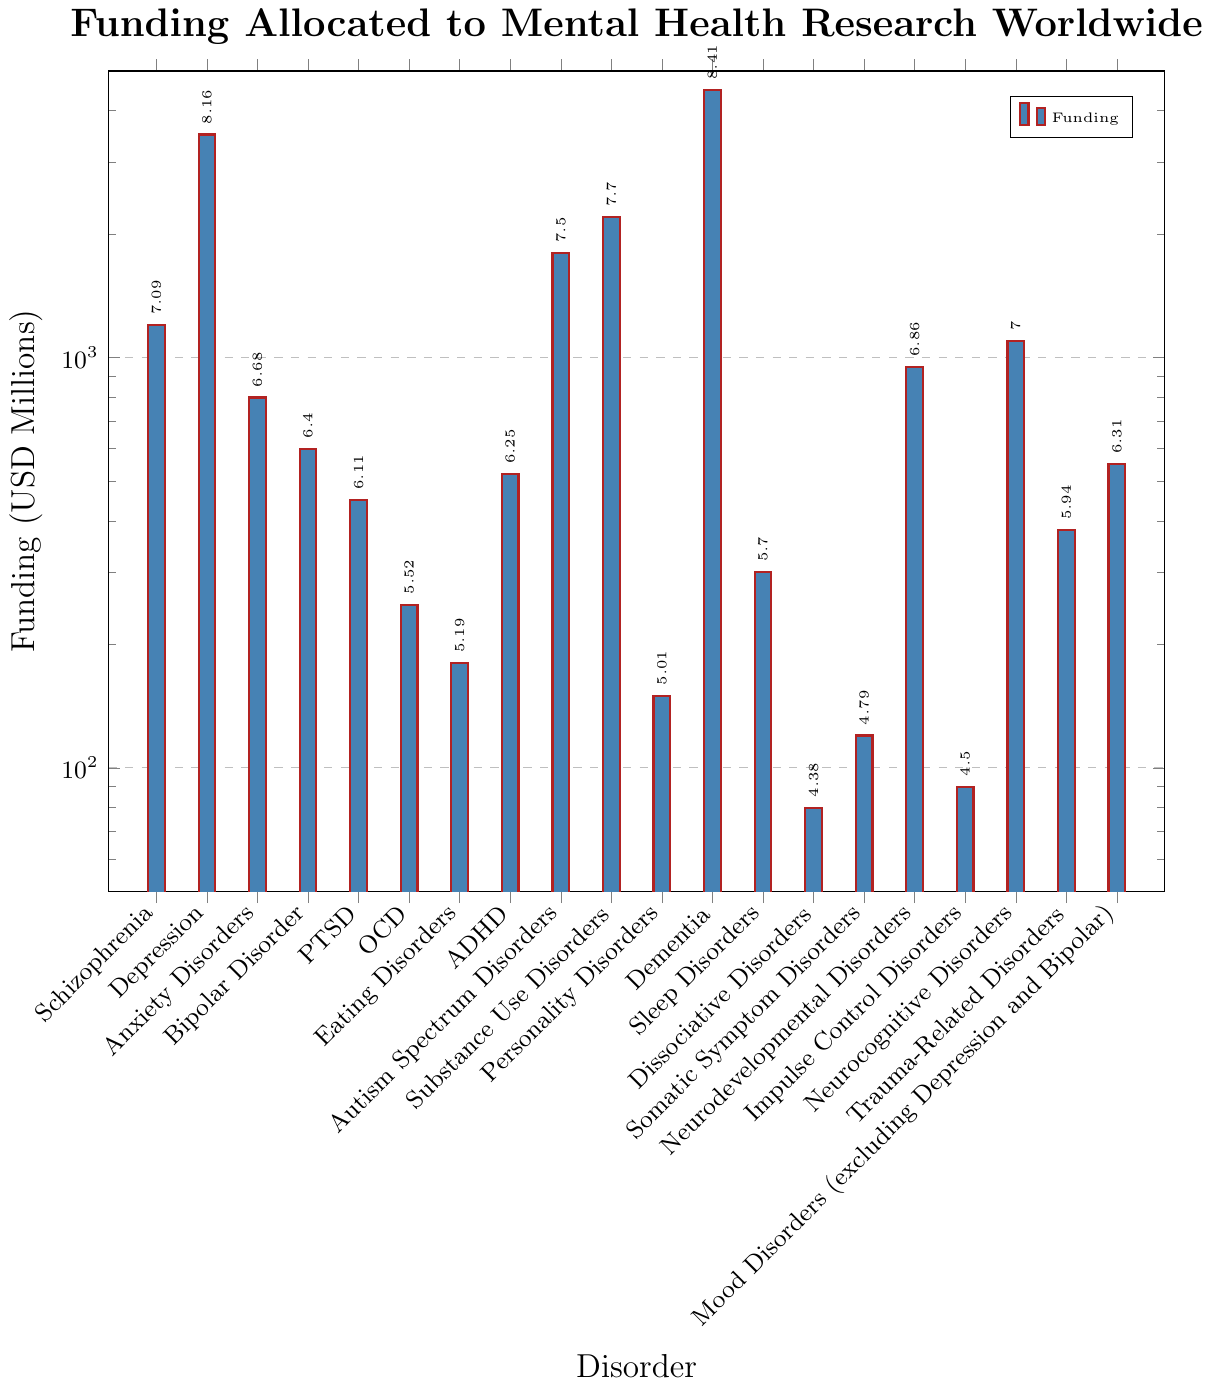Which disorder received the highest amount of funding? By looking at the highest bar on the chart, which represents the funding amount, we can see that Dementia received the highest amount of funding.
Answer: Dementia What is the funding difference between Schizophrenia and Depression? Find the heights of the bars representing Schizophrenia and Depression, which are $1200$ million and $3500$ million, respectively. Subtract the smaller amount from the larger amount: $3500 - 1200 = 2300$.
Answer: 2300 Which two disorders received exactly the same amount of funding? By examining the bars and their corresponding funding values, we can see that PTSD and Dementia both received $450$ million.
Answer: PTSD, Dementia What is the combined funding for Anxiety Disorders, PTSD, and OCD? Add the funding amounts for Anxiety Disorders ($800$ million), PTSD ($450$ million), and OCD ($250$ million): $800 + 450 + 250 = 1500$.
Answer: 1500 How does the funding for Neurodevelopmental Disorders compare to that of Neurocognitive Disorders? By comparing the heights of the bars, we can see that the funding for Neurodevelopmental Disorders is $950$ million, whereas for Neurocognitive Disorders it is $1100$ million. Therefore, Neurodevelopmental Disorders received less funding.
Answer: Neurodevelopmental Disorders received less funding What percentage of the total funding does Schizophrenia receive (considering only the disorders presented)? First, sum the total funding by adding the funding amounts of all the disorders: $1200 + 3500 + 800 + 600 + 450 + 250 + 180 + 520 + 1800 + 2200 + 150 + 4500 + 300 + 80 + 120 + 950 + 90 + 1100 + 380 + 550 = 20720$. Then, divide Schizophrenia's funding by the total funding and multiply by 100 to get the percentage: $\frac{1200}{20720} \times 100 \approx 5.79\%$.
Answer: 5.79% Which disorder has the second least amount of funding, and how much is it? By examining the heights of the bars from smallest to largest, the second least amount of funding is Dissociative Disorders with $80$ million. The smallest is Impulse Control Disorders with $90$ million.
Answer: Dissociative Disorders, 80 What is the average funding amount for PTSD, Sleep Disorders, and Dissociative Disorders? Sum the funding amounts for PTSD ($450$ million), Sleep Disorders ($300$ million), and Dissociative Disorders ($80$ million): $450 + 300 + 80 = 830$. Then, divide by the number of disorders, which is $3$: $\frac{830}{3} \approx 276.67$.
Answer: 276.67 